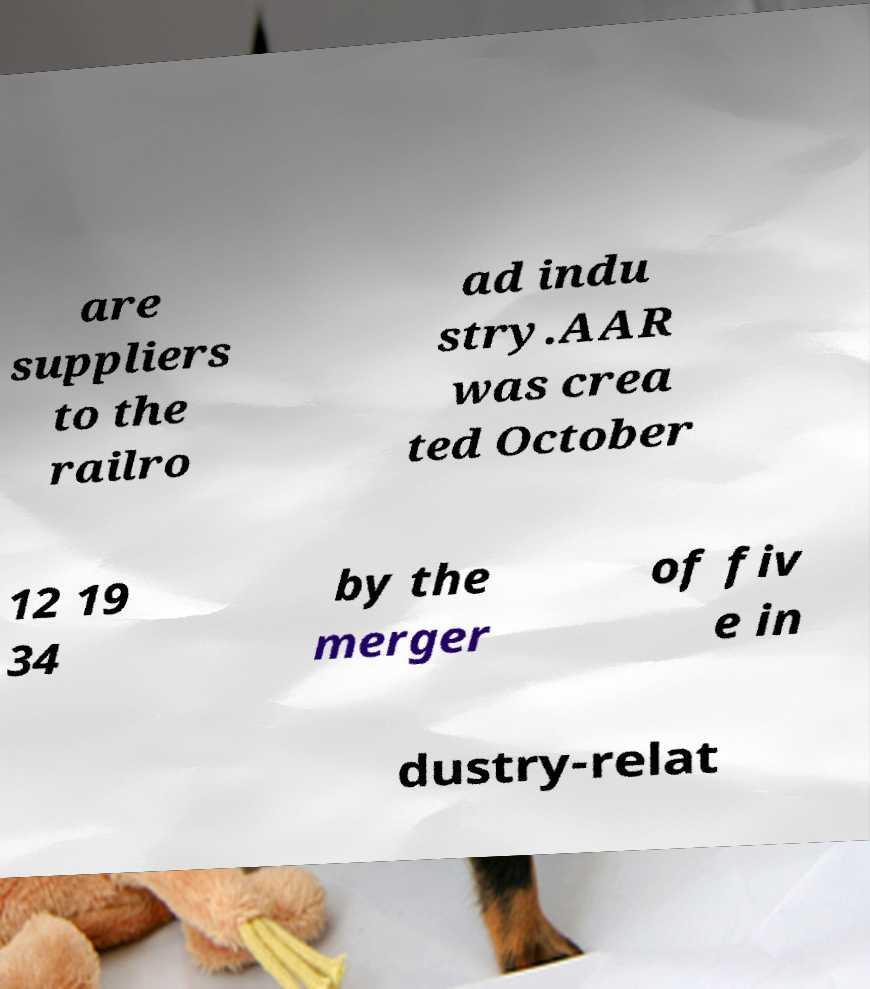Could you assist in decoding the text presented in this image and type it out clearly? are suppliers to the railro ad indu stry.AAR was crea ted October 12 19 34 by the merger of fiv e in dustry-relat 